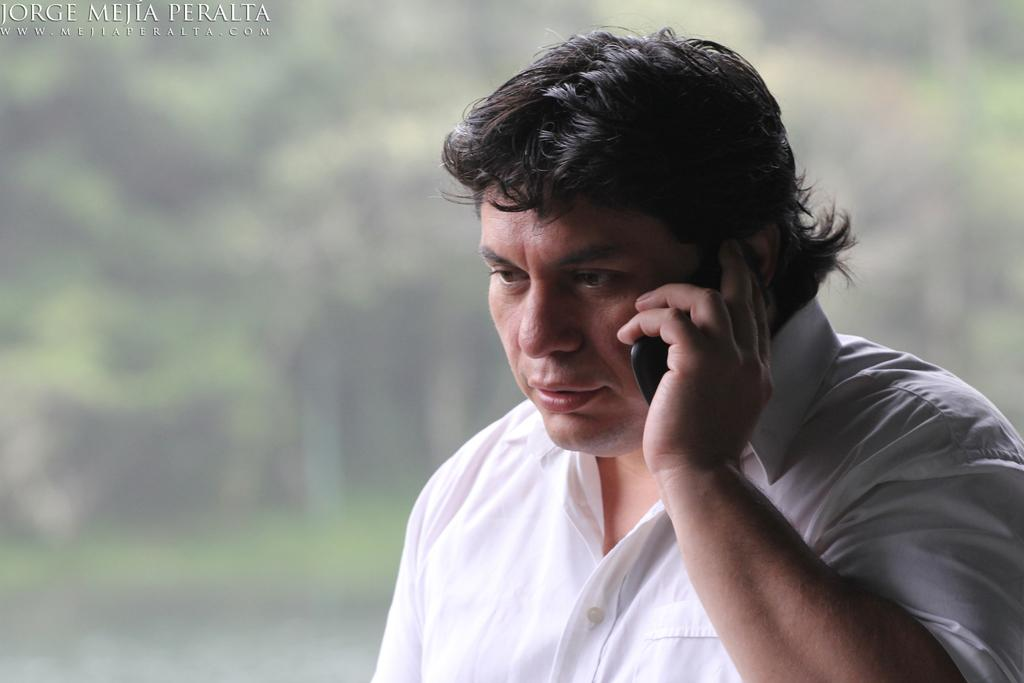What is the main subject of the image? There is a man in the middle of the image. What is the man wearing? The man is wearing a white shirt. What is the man holding in the image? The man is holding a mobile. What can be seen at the top of the image? There is text visible at the top of the image. What type of environment is visible in the background of the image? There is greenery in the background of the image. Can you see any leather or cobwebs in the image? No, there is no leather or cobwebs present in the image. Is there a pig visible in the image? No, there is no pig visible in the image. 